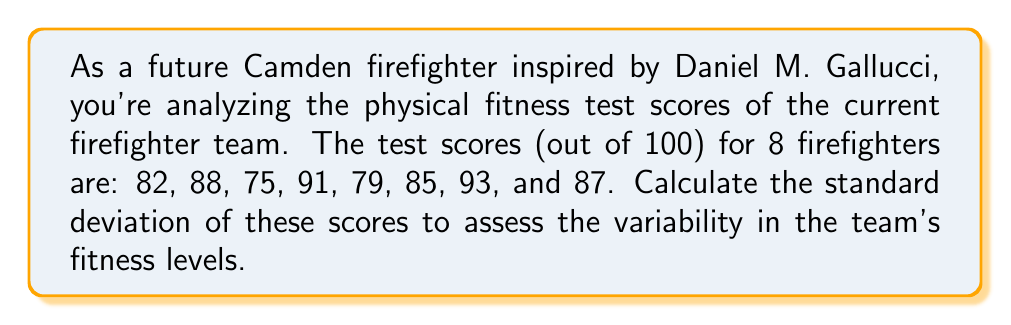Help me with this question. To calculate the standard deviation, we'll follow these steps:

1. Calculate the mean ($\bar{x}$) of the scores:
   $$\bar{x} = \frac{82 + 88 + 75 + 91 + 79 + 85 + 93 + 87}{8} = 85$$

2. Calculate the squared differences from the mean:
   $$(82 - 85)^2 = 9$$
   $$(88 - 85)^2 = 9$$
   $$(75 - 85)^2 = 100$$
   $$(91 - 85)^2 = 36$$
   $$(79 - 85)^2 = 36$$
   $$(85 - 85)^2 = 0$$
   $$(93 - 85)^2 = 64$$
   $$(87 - 85)^2 = 4$$

3. Calculate the sum of squared differences:
   $$9 + 9 + 100 + 36 + 36 + 0 + 64 + 4 = 258$$

4. Calculate the variance by dividing the sum of squared differences by (n - 1), where n is the number of scores:
   $$s^2 = \frac{258}{8 - 1} = \frac{258}{7} = 36.86$$

5. Calculate the standard deviation by taking the square root of the variance:
   $$s = \sqrt{36.86} = 6.07$$

Therefore, the standard deviation of the firefighter physical fitness test scores is approximately 6.07.
Answer: $6.07$ (rounded to two decimal places) 